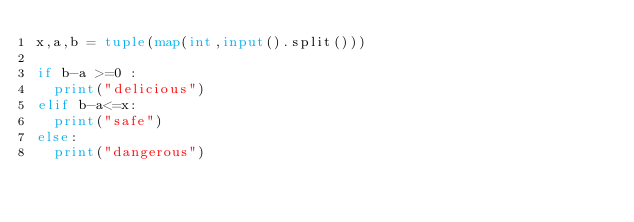Convert code to text. <code><loc_0><loc_0><loc_500><loc_500><_Python_>x,a,b = tuple(map(int,input().split()))
 
if b-a >=0 :
  print("delicious")
elif b-a<=x:
  print("safe")
else:
  print("dangerous")
</code> 